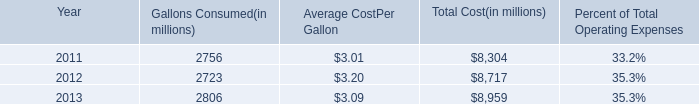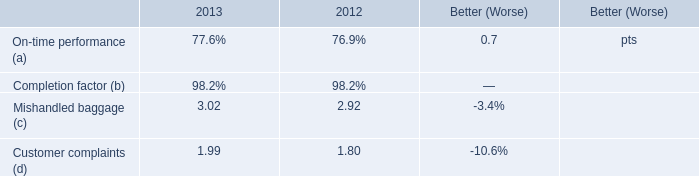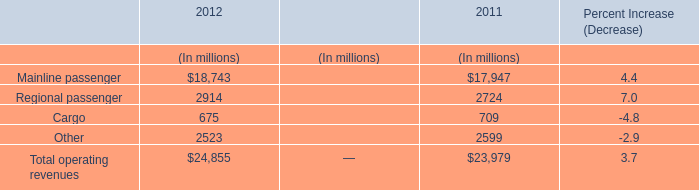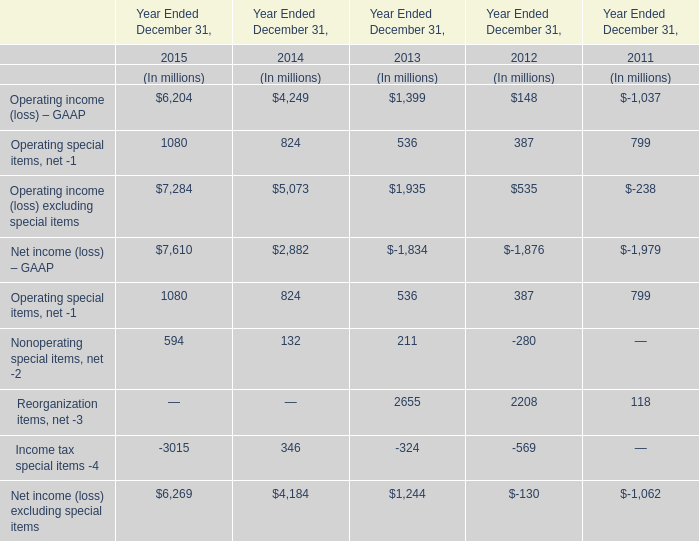What is the proportion of Operating income (loss) – GAAP to the total in 2015? 
Computations: (6204 / 7284)
Answer: 0.85173. 